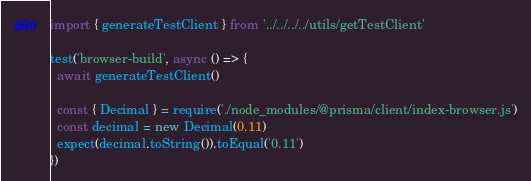Convert code to text. <code><loc_0><loc_0><loc_500><loc_500><_TypeScript_>import { generateTestClient } from '../../../../utils/getTestClient'

test('browser-build', async () => {
  await generateTestClient()

  const { Decimal } = require('./node_modules/@prisma/client/index-browser.js')
  const decimal = new Decimal(0.11)
  expect(decimal.toString()).toEqual('0.11')
})
</code> 